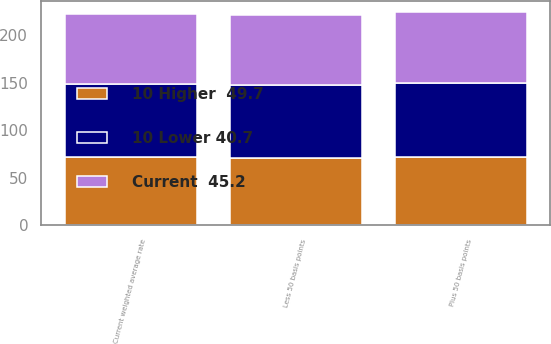Convert chart to OTSL. <chart><loc_0><loc_0><loc_500><loc_500><stacked_bar_chart><ecel><fcel>Less 50 basis points<fcel>Current weighted average rate<fcel>Plus 50 basis points<nl><fcel>10 Higher  49.7<fcel>70.7<fcel>71.3<fcel>72<nl><fcel>Current  45.2<fcel>73.6<fcel>74.1<fcel>74.8<nl><fcel>10 Lower 40.7<fcel>76.4<fcel>76.9<fcel>77.6<nl></chart> 